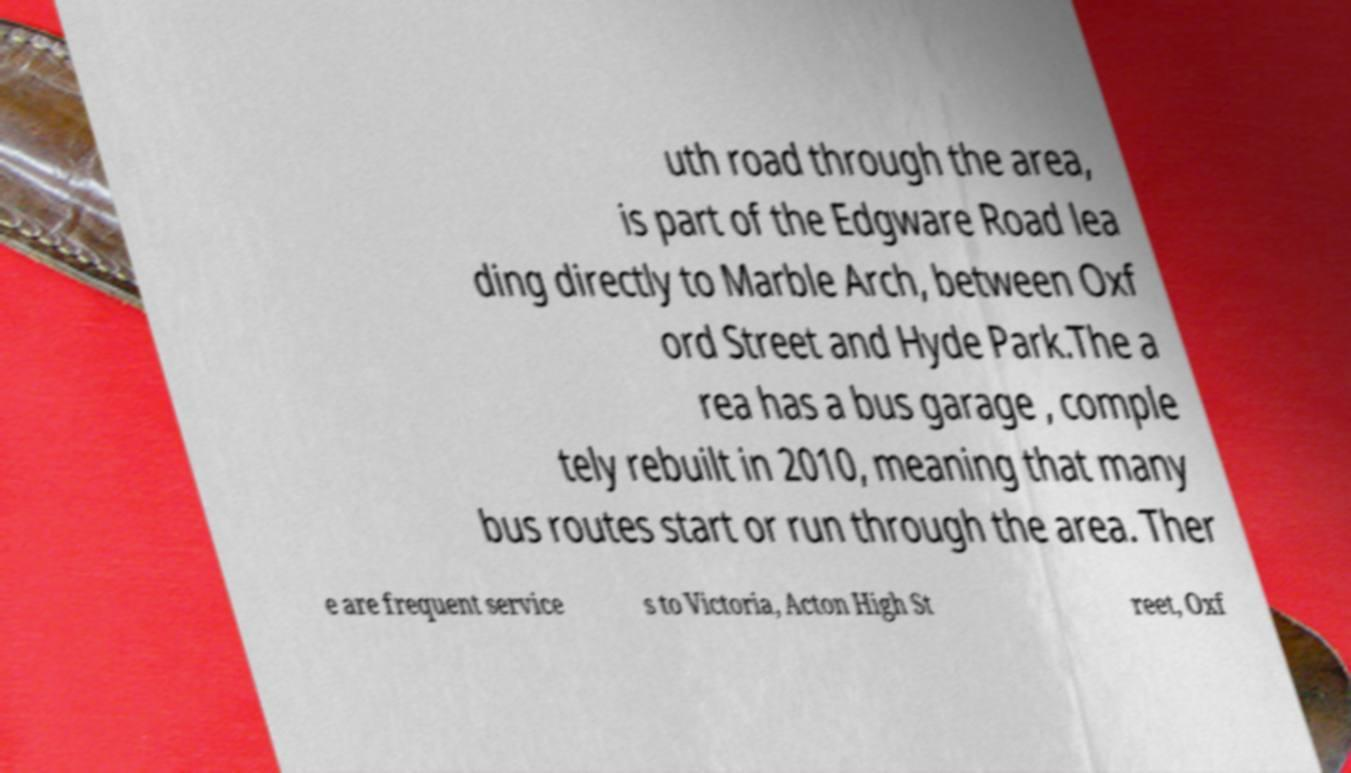Can you read and provide the text displayed in the image?This photo seems to have some interesting text. Can you extract and type it out for me? uth road through the area, is part of the Edgware Road lea ding directly to Marble Arch, between Oxf ord Street and Hyde Park.The a rea has a bus garage , comple tely rebuilt in 2010, meaning that many bus routes start or run through the area. Ther e are frequent service s to Victoria, Acton High St reet, Oxf 